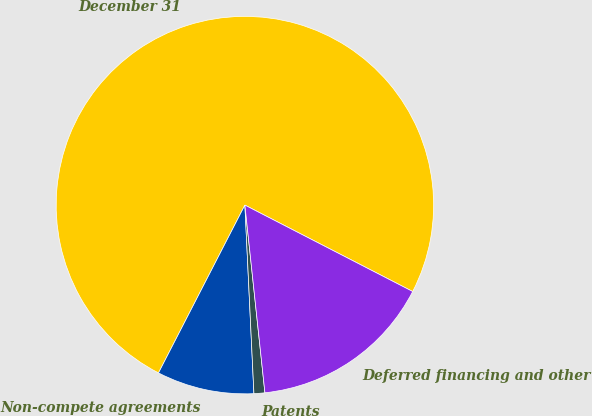Convert chart. <chart><loc_0><loc_0><loc_500><loc_500><pie_chart><fcel>December 31<fcel>Non-compete agreements<fcel>Patents<fcel>Deferred financing and other<nl><fcel>75.0%<fcel>8.33%<fcel>0.93%<fcel>15.74%<nl></chart> 